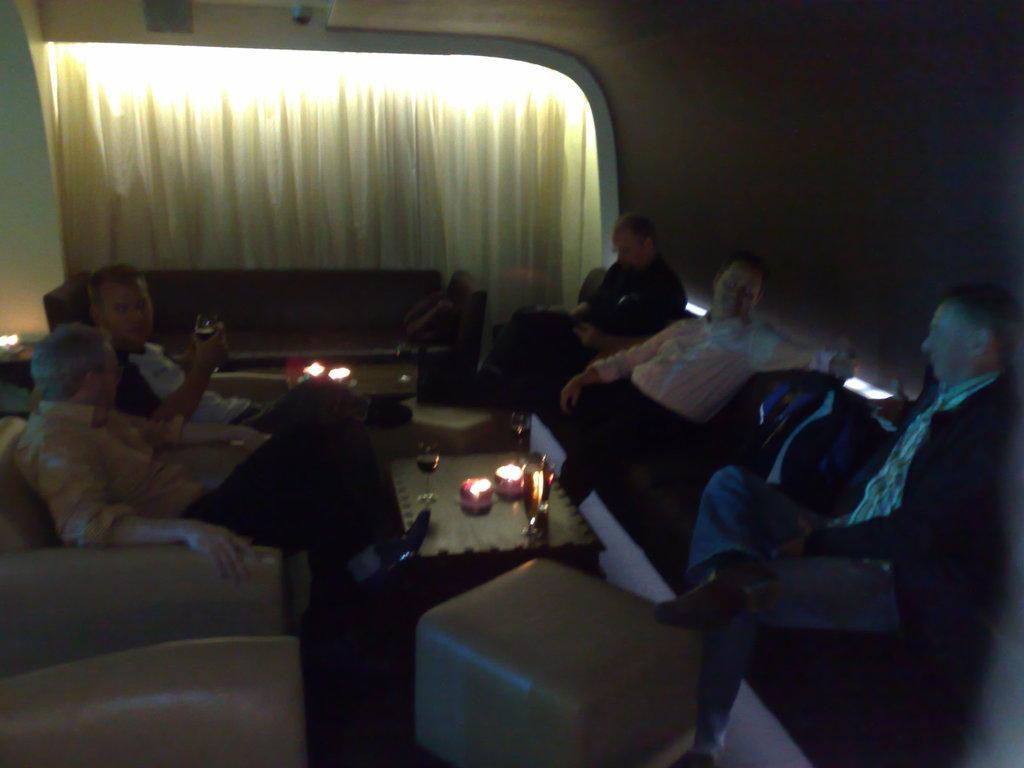Please provide a concise description of this image. In this picture we can see some persons are sitting on the sofa. This is table. On the table there is a glass, and a candle. On the background there is a curtain. 